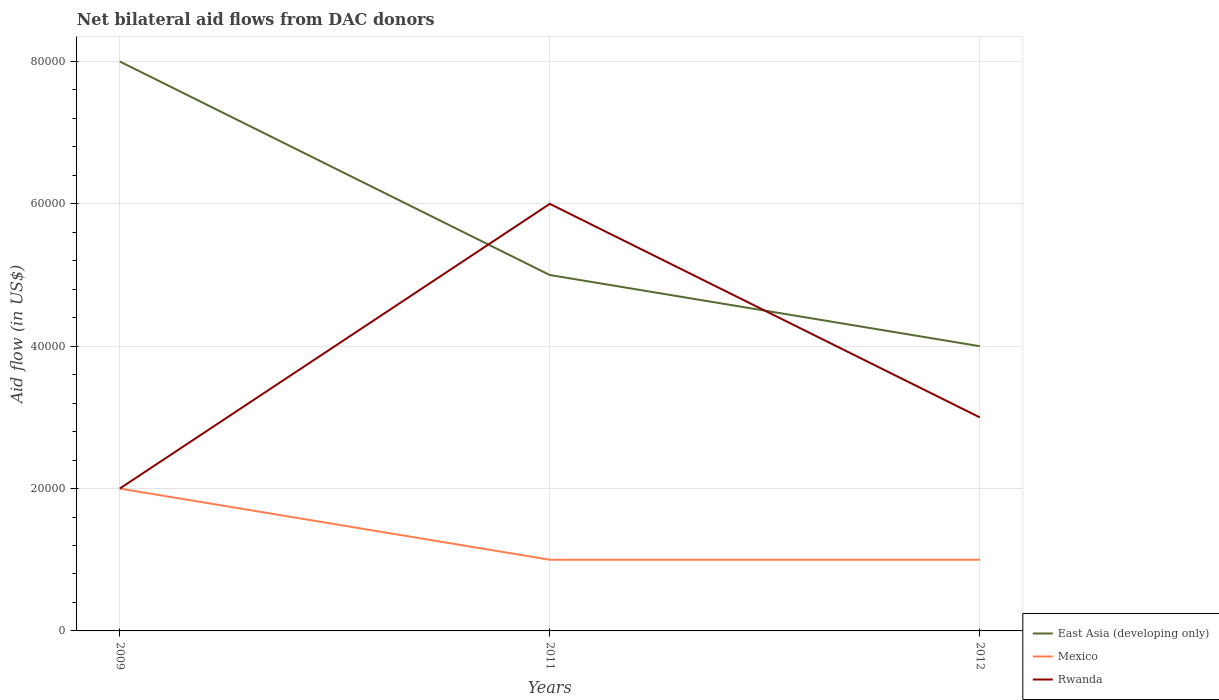How many different coloured lines are there?
Make the answer very short. 3. Across all years, what is the maximum net bilateral aid flow in East Asia (developing only)?
Give a very brief answer. 4.00e+04. What is the total net bilateral aid flow in Rwanda in the graph?
Provide a short and direct response. -4.00e+04. What is the difference between the highest and the second highest net bilateral aid flow in Rwanda?
Provide a short and direct response. 4.00e+04. Is the net bilateral aid flow in Mexico strictly greater than the net bilateral aid flow in Rwanda over the years?
Give a very brief answer. No. How many legend labels are there?
Offer a very short reply. 3. How are the legend labels stacked?
Provide a short and direct response. Vertical. What is the title of the graph?
Ensure brevity in your answer.  Net bilateral aid flows from DAC donors. What is the label or title of the X-axis?
Make the answer very short. Years. What is the label or title of the Y-axis?
Ensure brevity in your answer.  Aid flow (in US$). What is the Aid flow (in US$) in Mexico in 2011?
Ensure brevity in your answer.  10000. What is the Aid flow (in US$) in Rwanda in 2011?
Your response must be concise. 6.00e+04. What is the Aid flow (in US$) in East Asia (developing only) in 2012?
Your answer should be compact. 4.00e+04. Across all years, what is the maximum Aid flow (in US$) of East Asia (developing only)?
Provide a succinct answer. 8.00e+04. Across all years, what is the minimum Aid flow (in US$) in East Asia (developing only)?
Ensure brevity in your answer.  4.00e+04. Across all years, what is the minimum Aid flow (in US$) in Rwanda?
Your answer should be compact. 2.00e+04. What is the total Aid flow (in US$) of Mexico in the graph?
Ensure brevity in your answer.  4.00e+04. What is the total Aid flow (in US$) of Rwanda in the graph?
Offer a very short reply. 1.10e+05. What is the difference between the Aid flow (in US$) of East Asia (developing only) in 2009 and that in 2011?
Give a very brief answer. 3.00e+04. What is the difference between the Aid flow (in US$) of East Asia (developing only) in 2009 and that in 2012?
Your answer should be very brief. 4.00e+04. What is the difference between the Aid flow (in US$) of Mexico in 2009 and that in 2012?
Offer a terse response. 10000. What is the difference between the Aid flow (in US$) in East Asia (developing only) in 2011 and that in 2012?
Offer a terse response. 10000. What is the difference between the Aid flow (in US$) in Mexico in 2011 and that in 2012?
Your answer should be compact. 0. What is the difference between the Aid flow (in US$) in Rwanda in 2011 and that in 2012?
Ensure brevity in your answer.  3.00e+04. What is the difference between the Aid flow (in US$) in East Asia (developing only) in 2009 and the Aid flow (in US$) in Mexico in 2011?
Your answer should be very brief. 7.00e+04. What is the difference between the Aid flow (in US$) in Mexico in 2009 and the Aid flow (in US$) in Rwanda in 2011?
Your answer should be very brief. -4.00e+04. What is the difference between the Aid flow (in US$) in East Asia (developing only) in 2009 and the Aid flow (in US$) in Mexico in 2012?
Your answer should be very brief. 7.00e+04. What is the difference between the Aid flow (in US$) in East Asia (developing only) in 2009 and the Aid flow (in US$) in Rwanda in 2012?
Your response must be concise. 5.00e+04. What is the difference between the Aid flow (in US$) of Mexico in 2009 and the Aid flow (in US$) of Rwanda in 2012?
Give a very brief answer. -10000. What is the difference between the Aid flow (in US$) in East Asia (developing only) in 2011 and the Aid flow (in US$) in Mexico in 2012?
Keep it short and to the point. 4.00e+04. What is the average Aid flow (in US$) of East Asia (developing only) per year?
Offer a very short reply. 5.67e+04. What is the average Aid flow (in US$) in Mexico per year?
Give a very brief answer. 1.33e+04. What is the average Aid flow (in US$) in Rwanda per year?
Your answer should be compact. 3.67e+04. In the year 2009, what is the difference between the Aid flow (in US$) in Mexico and Aid flow (in US$) in Rwanda?
Offer a terse response. 0. In the year 2011, what is the difference between the Aid flow (in US$) in Mexico and Aid flow (in US$) in Rwanda?
Your response must be concise. -5.00e+04. In the year 2012, what is the difference between the Aid flow (in US$) of East Asia (developing only) and Aid flow (in US$) of Rwanda?
Offer a terse response. 10000. In the year 2012, what is the difference between the Aid flow (in US$) of Mexico and Aid flow (in US$) of Rwanda?
Your answer should be very brief. -2.00e+04. What is the ratio of the Aid flow (in US$) of East Asia (developing only) in 2009 to that in 2011?
Your answer should be compact. 1.6. What is the ratio of the Aid flow (in US$) in Mexico in 2009 to that in 2011?
Your response must be concise. 2. What is the ratio of the Aid flow (in US$) of East Asia (developing only) in 2009 to that in 2012?
Keep it short and to the point. 2. What is the ratio of the Aid flow (in US$) of Mexico in 2009 to that in 2012?
Provide a succinct answer. 2. What is the ratio of the Aid flow (in US$) in Rwanda in 2009 to that in 2012?
Offer a very short reply. 0.67. What is the ratio of the Aid flow (in US$) in East Asia (developing only) in 2011 to that in 2012?
Ensure brevity in your answer.  1.25. What is the difference between the highest and the second highest Aid flow (in US$) of East Asia (developing only)?
Make the answer very short. 3.00e+04. What is the difference between the highest and the second highest Aid flow (in US$) in Mexico?
Your answer should be compact. 10000. What is the difference between the highest and the second highest Aid flow (in US$) of Rwanda?
Ensure brevity in your answer.  3.00e+04. 